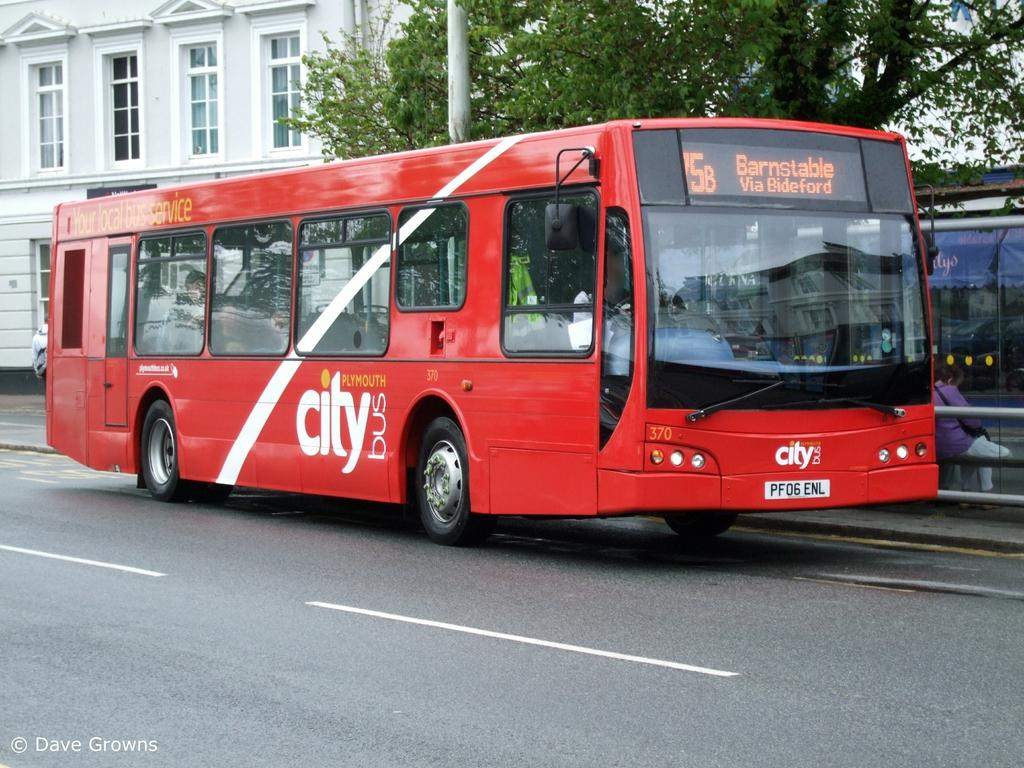Provide a one-sentence caption for the provided image. A red Plymouth city bus headed to Barnstable. 